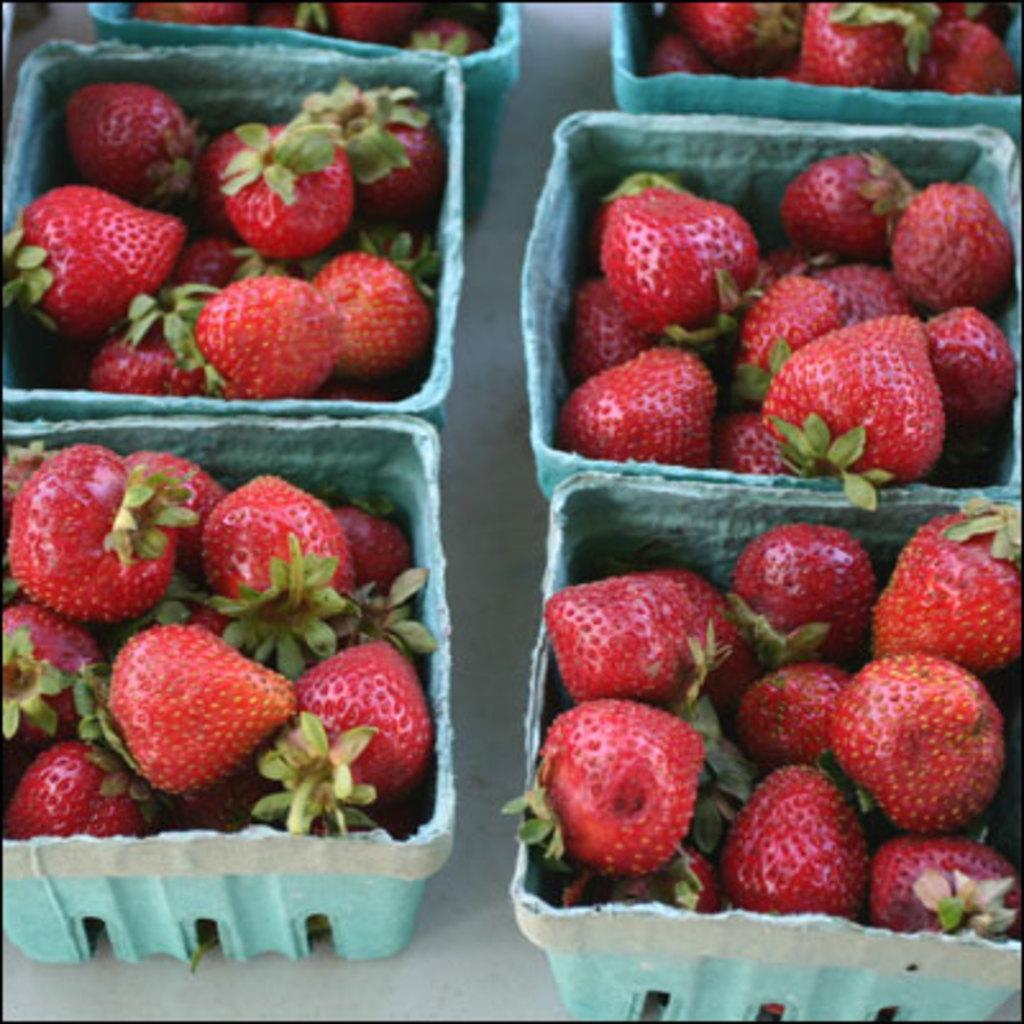Please provide a concise description of this image. In the image I can see the white colored surface and on it I can see blue colored trays. In the trays I can see strawberries which are red and green in color. 